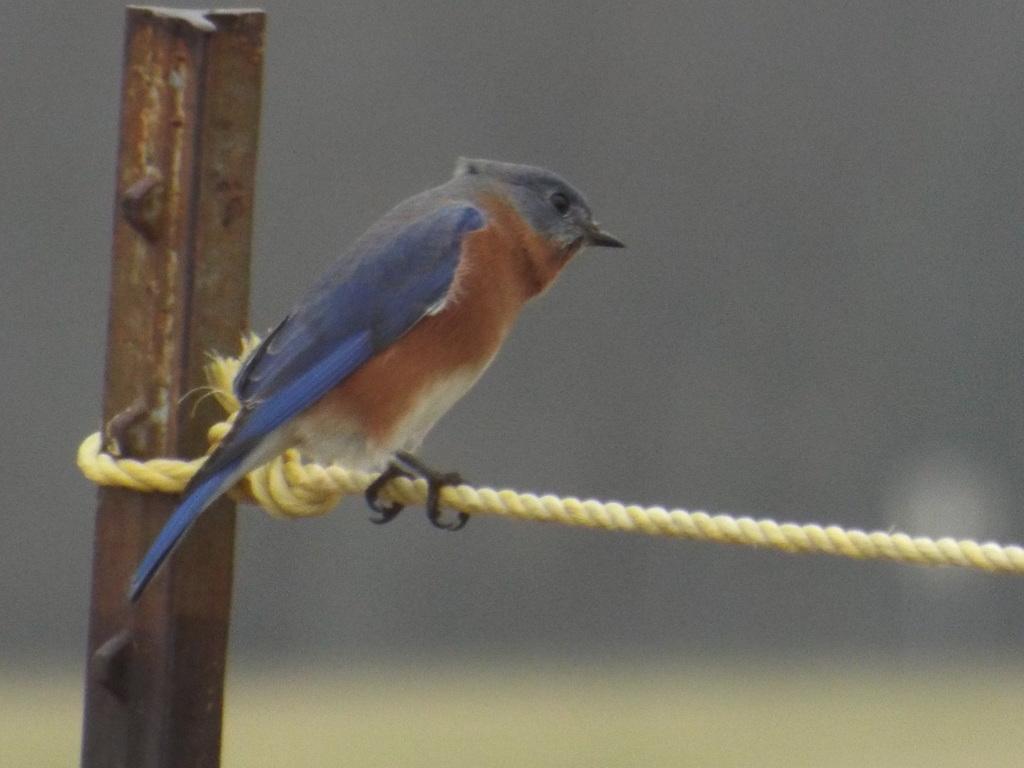Please provide a concise description of this image. On this hope we can see a bird. Background there is a rod and it is blurry. 